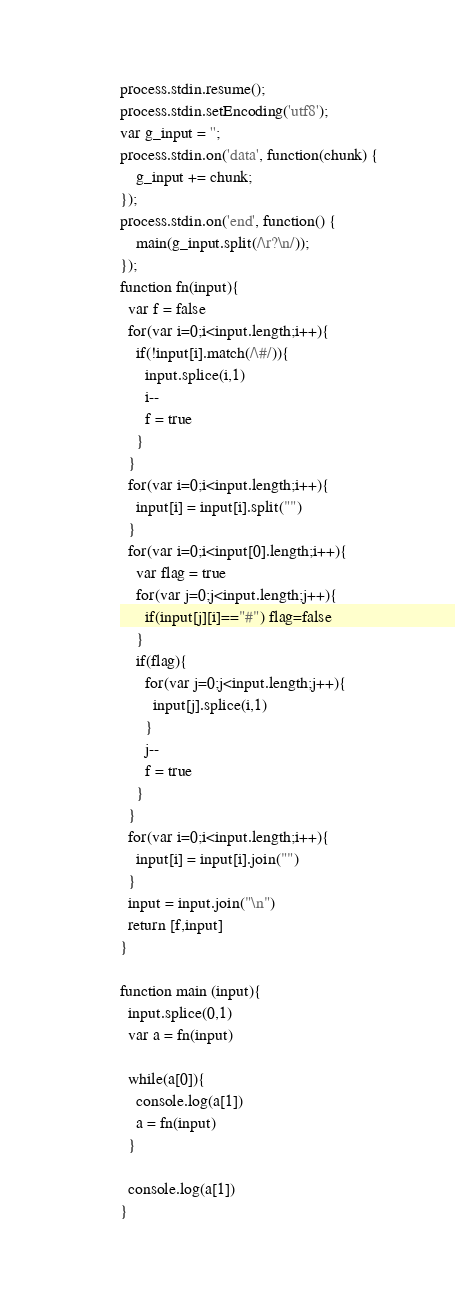<code> <loc_0><loc_0><loc_500><loc_500><_JavaScript_>process.stdin.resume();
process.stdin.setEncoding('utf8');
var g_input = '';
process.stdin.on('data', function(chunk) {
    g_input += chunk;
});
process.stdin.on('end', function() {
    main(g_input.split(/\r?\n/));
});
function fn(input){
  var f = false
  for(var i=0;i<input.length;i++){
    if(!input[i].match(/\#/)){
      input.splice(i,1)
      i--
      f = true
    }
  }
  for(var i=0;i<input.length;i++){
    input[i] = input[i].split("")
  }
  for(var i=0;i<input[0].length;i++){
    var flag = true
    for(var j=0;j<input.length;j++){
      if(input[j][i]=="#") flag=false
    }
    if(flag){
      for(var j=0;j<input.length;j++){
        input[j].splice(i,1)
      }
      j--
      f = true
    }
  }
  for(var i=0;i<input.length;i++){
    input[i] = input[i].join("")
  }
  input = input.join("\n")
  return [f,input]
}

function main (input){
  input.splice(0,1)
  var a = fn(input)
  
  while(a[0]){
    console.log(a[1])
    a = fn(input)
  }
  
  console.log(a[1])
}</code> 